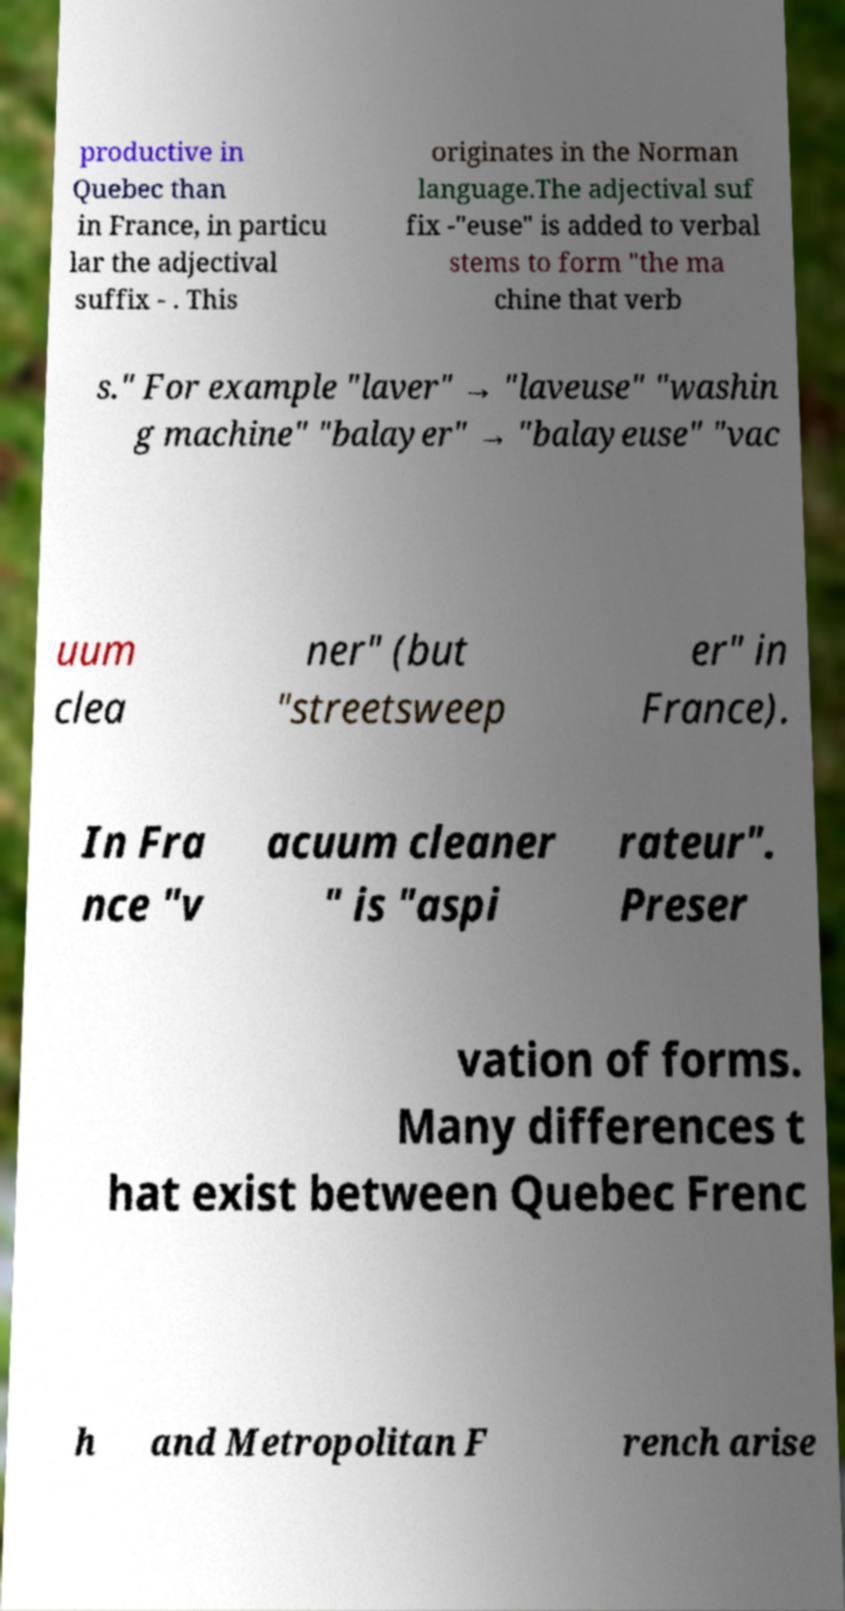For documentation purposes, I need the text within this image transcribed. Could you provide that? productive in Quebec than in France, in particu lar the adjectival suffix - . This originates in the Norman language.The adjectival suf fix -"euse" is added to verbal stems to form "the ma chine that verb s." For example "laver" → "laveuse" "washin g machine" "balayer" → "balayeuse" "vac uum clea ner" (but "streetsweep er" in France). In Fra nce "v acuum cleaner " is "aspi rateur". Preser vation of forms. Many differences t hat exist between Quebec Frenc h and Metropolitan F rench arise 